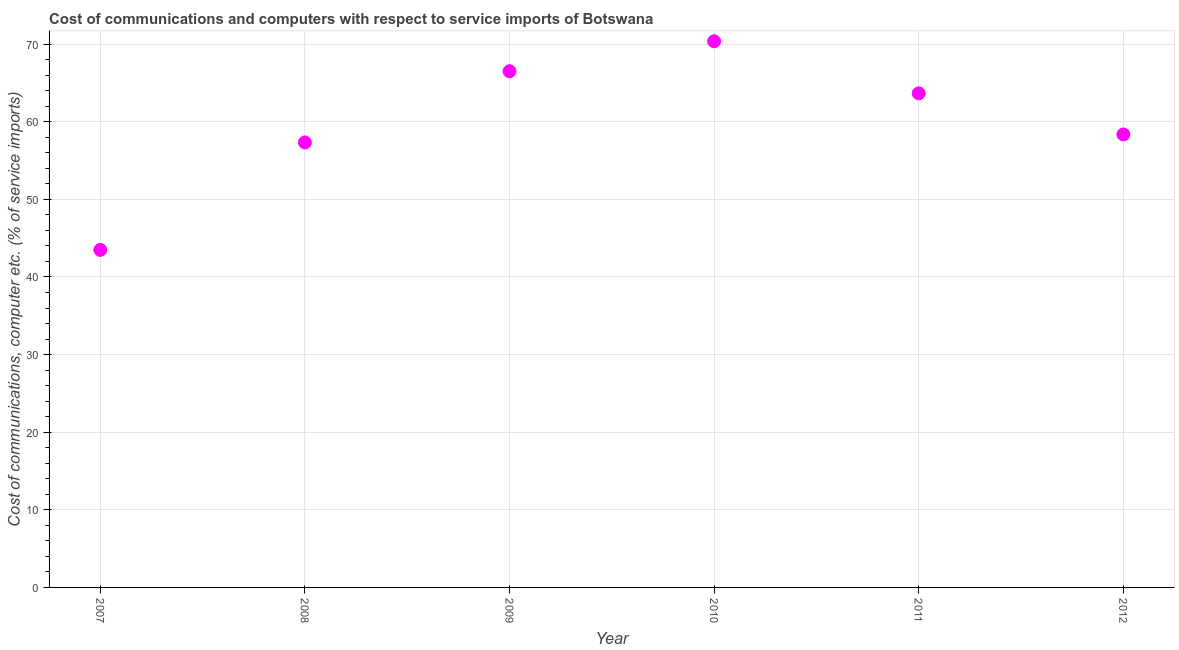What is the cost of communications and computer in 2012?
Your response must be concise. 58.36. Across all years, what is the maximum cost of communications and computer?
Offer a terse response. 70.37. Across all years, what is the minimum cost of communications and computer?
Your answer should be compact. 43.49. In which year was the cost of communications and computer minimum?
Ensure brevity in your answer.  2007. What is the sum of the cost of communications and computer?
Your response must be concise. 359.72. What is the difference between the cost of communications and computer in 2007 and 2008?
Keep it short and to the point. -13.85. What is the average cost of communications and computer per year?
Make the answer very short. 59.95. What is the median cost of communications and computer?
Provide a succinct answer. 61.01. What is the ratio of the cost of communications and computer in 2007 to that in 2010?
Make the answer very short. 0.62. Is the cost of communications and computer in 2008 less than that in 2010?
Offer a very short reply. Yes. What is the difference between the highest and the second highest cost of communications and computer?
Offer a terse response. 3.86. What is the difference between the highest and the lowest cost of communications and computer?
Offer a very short reply. 26.88. In how many years, is the cost of communications and computer greater than the average cost of communications and computer taken over all years?
Make the answer very short. 3. How many dotlines are there?
Provide a succinct answer. 1. How many years are there in the graph?
Your answer should be very brief. 6. Does the graph contain any zero values?
Your answer should be very brief. No. What is the title of the graph?
Keep it short and to the point. Cost of communications and computers with respect to service imports of Botswana. What is the label or title of the Y-axis?
Keep it short and to the point. Cost of communications, computer etc. (% of service imports). What is the Cost of communications, computer etc. (% of service imports) in 2007?
Your answer should be very brief. 43.49. What is the Cost of communications, computer etc. (% of service imports) in 2008?
Your response must be concise. 57.34. What is the Cost of communications, computer etc. (% of service imports) in 2009?
Keep it short and to the point. 66.51. What is the Cost of communications, computer etc. (% of service imports) in 2010?
Keep it short and to the point. 70.37. What is the Cost of communications, computer etc. (% of service imports) in 2011?
Provide a short and direct response. 63.66. What is the Cost of communications, computer etc. (% of service imports) in 2012?
Provide a succinct answer. 58.36. What is the difference between the Cost of communications, computer etc. (% of service imports) in 2007 and 2008?
Provide a short and direct response. -13.85. What is the difference between the Cost of communications, computer etc. (% of service imports) in 2007 and 2009?
Provide a short and direct response. -23.02. What is the difference between the Cost of communications, computer etc. (% of service imports) in 2007 and 2010?
Provide a short and direct response. -26.88. What is the difference between the Cost of communications, computer etc. (% of service imports) in 2007 and 2011?
Give a very brief answer. -20.17. What is the difference between the Cost of communications, computer etc. (% of service imports) in 2007 and 2012?
Your response must be concise. -14.87. What is the difference between the Cost of communications, computer etc. (% of service imports) in 2008 and 2009?
Keep it short and to the point. -9.17. What is the difference between the Cost of communications, computer etc. (% of service imports) in 2008 and 2010?
Provide a succinct answer. -13.03. What is the difference between the Cost of communications, computer etc. (% of service imports) in 2008 and 2011?
Ensure brevity in your answer.  -6.32. What is the difference between the Cost of communications, computer etc. (% of service imports) in 2008 and 2012?
Provide a short and direct response. -1.03. What is the difference between the Cost of communications, computer etc. (% of service imports) in 2009 and 2010?
Offer a very short reply. -3.86. What is the difference between the Cost of communications, computer etc. (% of service imports) in 2009 and 2011?
Make the answer very short. 2.85. What is the difference between the Cost of communications, computer etc. (% of service imports) in 2009 and 2012?
Provide a succinct answer. 8.15. What is the difference between the Cost of communications, computer etc. (% of service imports) in 2010 and 2011?
Offer a terse response. 6.71. What is the difference between the Cost of communications, computer etc. (% of service imports) in 2010 and 2012?
Keep it short and to the point. 12.01. What is the difference between the Cost of communications, computer etc. (% of service imports) in 2011 and 2012?
Your response must be concise. 5.3. What is the ratio of the Cost of communications, computer etc. (% of service imports) in 2007 to that in 2008?
Give a very brief answer. 0.76. What is the ratio of the Cost of communications, computer etc. (% of service imports) in 2007 to that in 2009?
Ensure brevity in your answer.  0.65. What is the ratio of the Cost of communications, computer etc. (% of service imports) in 2007 to that in 2010?
Keep it short and to the point. 0.62. What is the ratio of the Cost of communications, computer etc. (% of service imports) in 2007 to that in 2011?
Make the answer very short. 0.68. What is the ratio of the Cost of communications, computer etc. (% of service imports) in 2007 to that in 2012?
Give a very brief answer. 0.74. What is the ratio of the Cost of communications, computer etc. (% of service imports) in 2008 to that in 2009?
Your answer should be compact. 0.86. What is the ratio of the Cost of communications, computer etc. (% of service imports) in 2008 to that in 2010?
Provide a short and direct response. 0.81. What is the ratio of the Cost of communications, computer etc. (% of service imports) in 2008 to that in 2011?
Keep it short and to the point. 0.9. What is the ratio of the Cost of communications, computer etc. (% of service imports) in 2008 to that in 2012?
Offer a very short reply. 0.98. What is the ratio of the Cost of communications, computer etc. (% of service imports) in 2009 to that in 2010?
Offer a terse response. 0.94. What is the ratio of the Cost of communications, computer etc. (% of service imports) in 2009 to that in 2011?
Ensure brevity in your answer.  1.04. What is the ratio of the Cost of communications, computer etc. (% of service imports) in 2009 to that in 2012?
Your answer should be very brief. 1.14. What is the ratio of the Cost of communications, computer etc. (% of service imports) in 2010 to that in 2011?
Offer a terse response. 1.1. What is the ratio of the Cost of communications, computer etc. (% of service imports) in 2010 to that in 2012?
Your answer should be compact. 1.21. What is the ratio of the Cost of communications, computer etc. (% of service imports) in 2011 to that in 2012?
Your response must be concise. 1.09. 